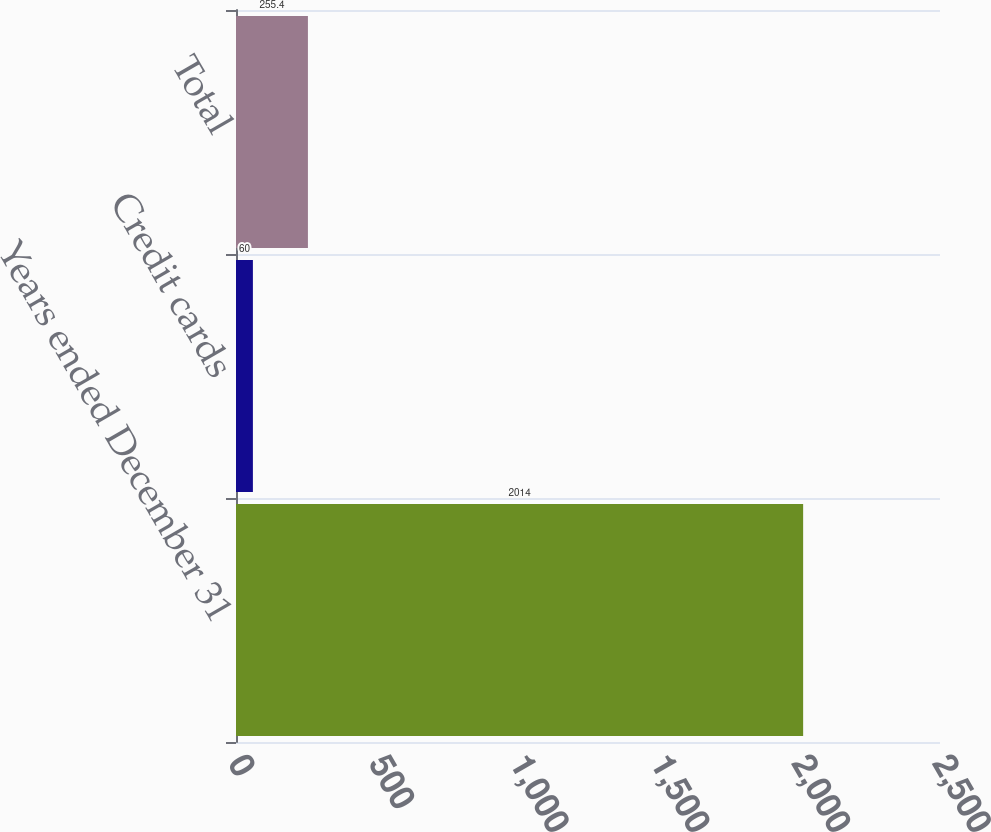Convert chart. <chart><loc_0><loc_0><loc_500><loc_500><bar_chart><fcel>Years ended December 31<fcel>Credit cards<fcel>Total<nl><fcel>2014<fcel>60<fcel>255.4<nl></chart> 